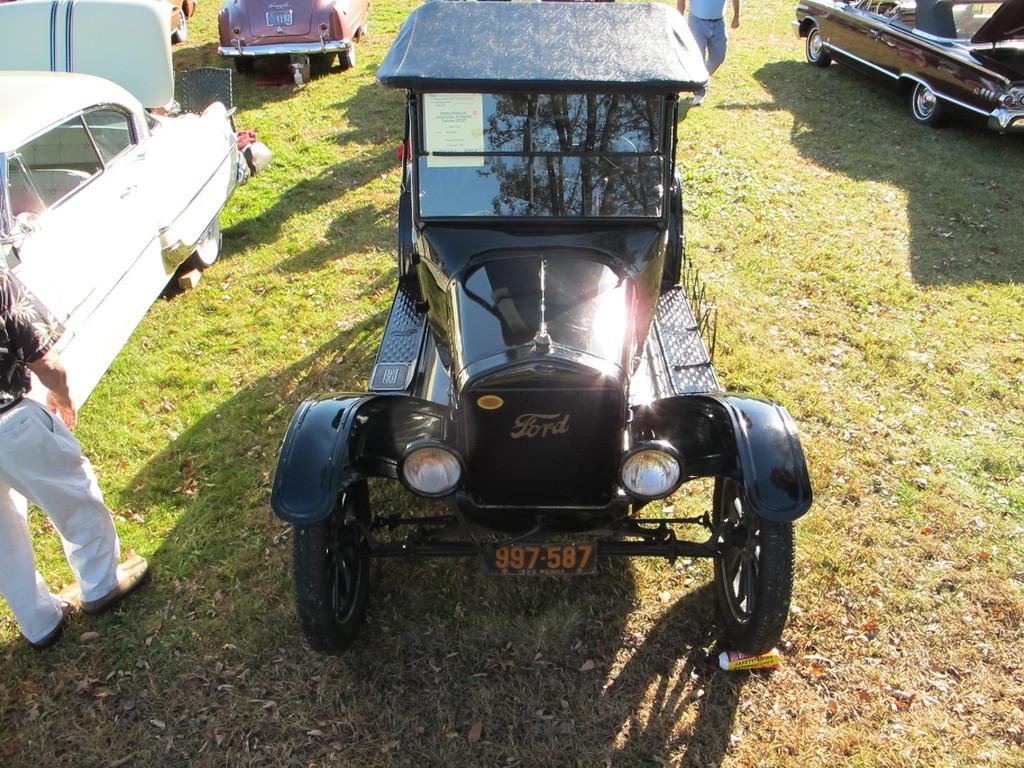What type of vehicles are in the image? There are antique cars in the image. Where are the cars located? The cars are parked on the grass. Are there any people present in the image? Yes, there are people walking on the grass in the image. How many oranges are being used as a makeshift roof for the tin shed in the image? There is no mention of oranges, a tin shed, or any makeshift roof in the image. 